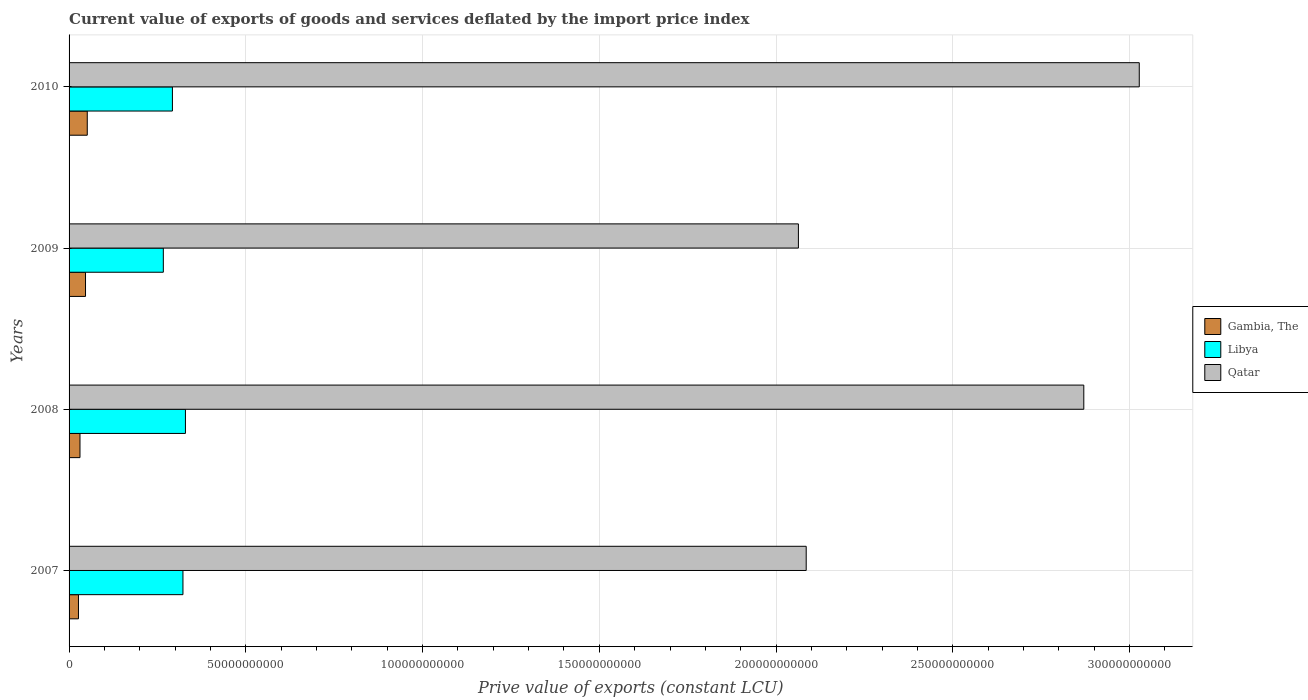How many different coloured bars are there?
Your answer should be compact. 3. How many groups of bars are there?
Make the answer very short. 4. Are the number of bars per tick equal to the number of legend labels?
Provide a short and direct response. Yes. Are the number of bars on each tick of the Y-axis equal?
Make the answer very short. Yes. How many bars are there on the 2nd tick from the bottom?
Provide a succinct answer. 3. What is the label of the 4th group of bars from the top?
Give a very brief answer. 2007. What is the prive value of exports in Qatar in 2007?
Keep it short and to the point. 2.09e+11. Across all years, what is the maximum prive value of exports in Qatar?
Your response must be concise. 3.03e+11. Across all years, what is the minimum prive value of exports in Qatar?
Give a very brief answer. 2.06e+11. In which year was the prive value of exports in Libya maximum?
Offer a very short reply. 2008. In which year was the prive value of exports in Gambia, The minimum?
Ensure brevity in your answer.  2007. What is the total prive value of exports in Gambia, The in the graph?
Your answer should be compact. 1.55e+1. What is the difference between the prive value of exports in Gambia, The in 2007 and that in 2009?
Keep it short and to the point. -1.99e+09. What is the difference between the prive value of exports in Qatar in 2009 and the prive value of exports in Libya in 2008?
Give a very brief answer. 1.73e+11. What is the average prive value of exports in Qatar per year?
Provide a short and direct response. 2.51e+11. In the year 2008, what is the difference between the prive value of exports in Gambia, The and prive value of exports in Qatar?
Offer a very short reply. -2.84e+11. What is the ratio of the prive value of exports in Libya in 2009 to that in 2010?
Offer a terse response. 0.91. Is the prive value of exports in Libya in 2008 less than that in 2010?
Ensure brevity in your answer.  No. What is the difference between the highest and the second highest prive value of exports in Qatar?
Provide a succinct answer. 1.57e+1. What is the difference between the highest and the lowest prive value of exports in Gambia, The?
Make the answer very short. 2.49e+09. In how many years, is the prive value of exports in Gambia, The greater than the average prive value of exports in Gambia, The taken over all years?
Provide a short and direct response. 2. What does the 2nd bar from the top in 2009 represents?
Offer a terse response. Libya. What does the 3rd bar from the bottom in 2007 represents?
Offer a terse response. Qatar. Is it the case that in every year, the sum of the prive value of exports in Qatar and prive value of exports in Libya is greater than the prive value of exports in Gambia, The?
Provide a short and direct response. Yes. Are all the bars in the graph horizontal?
Make the answer very short. Yes. Are the values on the major ticks of X-axis written in scientific E-notation?
Offer a terse response. No. How many legend labels are there?
Provide a short and direct response. 3. What is the title of the graph?
Provide a short and direct response. Current value of exports of goods and services deflated by the import price index. What is the label or title of the X-axis?
Your answer should be compact. Prive value of exports (constant LCU). What is the label or title of the Y-axis?
Make the answer very short. Years. What is the Prive value of exports (constant LCU) in Gambia, The in 2007?
Provide a short and direct response. 2.66e+09. What is the Prive value of exports (constant LCU) in Libya in 2007?
Your answer should be compact. 3.22e+1. What is the Prive value of exports (constant LCU) in Qatar in 2007?
Give a very brief answer. 2.09e+11. What is the Prive value of exports (constant LCU) of Gambia, The in 2008?
Keep it short and to the point. 3.09e+09. What is the Prive value of exports (constant LCU) of Libya in 2008?
Provide a short and direct response. 3.29e+1. What is the Prive value of exports (constant LCU) in Qatar in 2008?
Your answer should be very brief. 2.87e+11. What is the Prive value of exports (constant LCU) in Gambia, The in 2009?
Your response must be concise. 4.65e+09. What is the Prive value of exports (constant LCU) in Libya in 2009?
Keep it short and to the point. 2.67e+1. What is the Prive value of exports (constant LCU) in Qatar in 2009?
Your response must be concise. 2.06e+11. What is the Prive value of exports (constant LCU) of Gambia, The in 2010?
Ensure brevity in your answer.  5.15e+09. What is the Prive value of exports (constant LCU) in Libya in 2010?
Your answer should be very brief. 2.92e+1. What is the Prive value of exports (constant LCU) in Qatar in 2010?
Give a very brief answer. 3.03e+11. Across all years, what is the maximum Prive value of exports (constant LCU) of Gambia, The?
Give a very brief answer. 5.15e+09. Across all years, what is the maximum Prive value of exports (constant LCU) in Libya?
Your answer should be compact. 3.29e+1. Across all years, what is the maximum Prive value of exports (constant LCU) in Qatar?
Make the answer very short. 3.03e+11. Across all years, what is the minimum Prive value of exports (constant LCU) in Gambia, The?
Your answer should be very brief. 2.66e+09. Across all years, what is the minimum Prive value of exports (constant LCU) of Libya?
Provide a succinct answer. 2.67e+1. Across all years, what is the minimum Prive value of exports (constant LCU) of Qatar?
Provide a succinct answer. 2.06e+11. What is the total Prive value of exports (constant LCU) in Gambia, The in the graph?
Give a very brief answer. 1.55e+1. What is the total Prive value of exports (constant LCU) of Libya in the graph?
Your answer should be compact. 1.21e+11. What is the total Prive value of exports (constant LCU) of Qatar in the graph?
Ensure brevity in your answer.  1.00e+12. What is the difference between the Prive value of exports (constant LCU) of Gambia, The in 2007 and that in 2008?
Provide a short and direct response. -4.27e+08. What is the difference between the Prive value of exports (constant LCU) in Libya in 2007 and that in 2008?
Offer a terse response. -7.04e+08. What is the difference between the Prive value of exports (constant LCU) in Qatar in 2007 and that in 2008?
Your response must be concise. -7.85e+1. What is the difference between the Prive value of exports (constant LCU) in Gambia, The in 2007 and that in 2009?
Give a very brief answer. -1.99e+09. What is the difference between the Prive value of exports (constant LCU) of Libya in 2007 and that in 2009?
Make the answer very short. 5.55e+09. What is the difference between the Prive value of exports (constant LCU) in Qatar in 2007 and that in 2009?
Your answer should be compact. 2.21e+09. What is the difference between the Prive value of exports (constant LCU) in Gambia, The in 2007 and that in 2010?
Provide a short and direct response. -2.49e+09. What is the difference between the Prive value of exports (constant LCU) in Libya in 2007 and that in 2010?
Keep it short and to the point. 2.98e+09. What is the difference between the Prive value of exports (constant LCU) in Qatar in 2007 and that in 2010?
Provide a short and direct response. -9.42e+1. What is the difference between the Prive value of exports (constant LCU) of Gambia, The in 2008 and that in 2009?
Offer a very short reply. -1.57e+09. What is the difference between the Prive value of exports (constant LCU) of Libya in 2008 and that in 2009?
Give a very brief answer. 6.26e+09. What is the difference between the Prive value of exports (constant LCU) in Qatar in 2008 and that in 2009?
Provide a short and direct response. 8.07e+1. What is the difference between the Prive value of exports (constant LCU) in Gambia, The in 2008 and that in 2010?
Give a very brief answer. -2.06e+09. What is the difference between the Prive value of exports (constant LCU) in Libya in 2008 and that in 2010?
Give a very brief answer. 3.68e+09. What is the difference between the Prive value of exports (constant LCU) in Qatar in 2008 and that in 2010?
Ensure brevity in your answer.  -1.57e+1. What is the difference between the Prive value of exports (constant LCU) of Gambia, The in 2009 and that in 2010?
Offer a very short reply. -4.93e+08. What is the difference between the Prive value of exports (constant LCU) in Libya in 2009 and that in 2010?
Give a very brief answer. -2.57e+09. What is the difference between the Prive value of exports (constant LCU) of Qatar in 2009 and that in 2010?
Give a very brief answer. -9.64e+1. What is the difference between the Prive value of exports (constant LCU) in Gambia, The in 2007 and the Prive value of exports (constant LCU) in Libya in 2008?
Give a very brief answer. -3.03e+1. What is the difference between the Prive value of exports (constant LCU) of Gambia, The in 2007 and the Prive value of exports (constant LCU) of Qatar in 2008?
Your answer should be compact. -2.84e+11. What is the difference between the Prive value of exports (constant LCU) in Libya in 2007 and the Prive value of exports (constant LCU) in Qatar in 2008?
Offer a terse response. -2.55e+11. What is the difference between the Prive value of exports (constant LCU) in Gambia, The in 2007 and the Prive value of exports (constant LCU) in Libya in 2009?
Keep it short and to the point. -2.40e+1. What is the difference between the Prive value of exports (constant LCU) of Gambia, The in 2007 and the Prive value of exports (constant LCU) of Qatar in 2009?
Give a very brief answer. -2.04e+11. What is the difference between the Prive value of exports (constant LCU) of Libya in 2007 and the Prive value of exports (constant LCU) of Qatar in 2009?
Offer a very short reply. -1.74e+11. What is the difference between the Prive value of exports (constant LCU) in Gambia, The in 2007 and the Prive value of exports (constant LCU) in Libya in 2010?
Provide a short and direct response. -2.66e+1. What is the difference between the Prive value of exports (constant LCU) of Gambia, The in 2007 and the Prive value of exports (constant LCU) of Qatar in 2010?
Provide a succinct answer. -3.00e+11. What is the difference between the Prive value of exports (constant LCU) of Libya in 2007 and the Prive value of exports (constant LCU) of Qatar in 2010?
Offer a terse response. -2.71e+11. What is the difference between the Prive value of exports (constant LCU) of Gambia, The in 2008 and the Prive value of exports (constant LCU) of Libya in 2009?
Offer a very short reply. -2.36e+1. What is the difference between the Prive value of exports (constant LCU) in Gambia, The in 2008 and the Prive value of exports (constant LCU) in Qatar in 2009?
Make the answer very short. -2.03e+11. What is the difference between the Prive value of exports (constant LCU) of Libya in 2008 and the Prive value of exports (constant LCU) of Qatar in 2009?
Provide a succinct answer. -1.73e+11. What is the difference between the Prive value of exports (constant LCU) of Gambia, The in 2008 and the Prive value of exports (constant LCU) of Libya in 2010?
Your response must be concise. -2.61e+1. What is the difference between the Prive value of exports (constant LCU) of Gambia, The in 2008 and the Prive value of exports (constant LCU) of Qatar in 2010?
Your response must be concise. -3.00e+11. What is the difference between the Prive value of exports (constant LCU) of Libya in 2008 and the Prive value of exports (constant LCU) of Qatar in 2010?
Make the answer very short. -2.70e+11. What is the difference between the Prive value of exports (constant LCU) of Gambia, The in 2009 and the Prive value of exports (constant LCU) of Libya in 2010?
Keep it short and to the point. -2.46e+1. What is the difference between the Prive value of exports (constant LCU) of Gambia, The in 2009 and the Prive value of exports (constant LCU) of Qatar in 2010?
Provide a short and direct response. -2.98e+11. What is the difference between the Prive value of exports (constant LCU) of Libya in 2009 and the Prive value of exports (constant LCU) of Qatar in 2010?
Your response must be concise. -2.76e+11. What is the average Prive value of exports (constant LCU) in Gambia, The per year?
Your answer should be very brief. 3.89e+09. What is the average Prive value of exports (constant LCU) of Libya per year?
Your answer should be compact. 3.03e+1. What is the average Prive value of exports (constant LCU) in Qatar per year?
Provide a short and direct response. 2.51e+11. In the year 2007, what is the difference between the Prive value of exports (constant LCU) of Gambia, The and Prive value of exports (constant LCU) of Libya?
Your answer should be compact. -2.96e+1. In the year 2007, what is the difference between the Prive value of exports (constant LCU) of Gambia, The and Prive value of exports (constant LCU) of Qatar?
Ensure brevity in your answer.  -2.06e+11. In the year 2007, what is the difference between the Prive value of exports (constant LCU) in Libya and Prive value of exports (constant LCU) in Qatar?
Your response must be concise. -1.76e+11. In the year 2008, what is the difference between the Prive value of exports (constant LCU) in Gambia, The and Prive value of exports (constant LCU) in Libya?
Ensure brevity in your answer.  -2.98e+1. In the year 2008, what is the difference between the Prive value of exports (constant LCU) of Gambia, The and Prive value of exports (constant LCU) of Qatar?
Your response must be concise. -2.84e+11. In the year 2008, what is the difference between the Prive value of exports (constant LCU) in Libya and Prive value of exports (constant LCU) in Qatar?
Offer a very short reply. -2.54e+11. In the year 2009, what is the difference between the Prive value of exports (constant LCU) of Gambia, The and Prive value of exports (constant LCU) of Libya?
Ensure brevity in your answer.  -2.20e+1. In the year 2009, what is the difference between the Prive value of exports (constant LCU) in Gambia, The and Prive value of exports (constant LCU) in Qatar?
Offer a very short reply. -2.02e+11. In the year 2009, what is the difference between the Prive value of exports (constant LCU) in Libya and Prive value of exports (constant LCU) in Qatar?
Your response must be concise. -1.80e+11. In the year 2010, what is the difference between the Prive value of exports (constant LCU) in Gambia, The and Prive value of exports (constant LCU) in Libya?
Keep it short and to the point. -2.41e+1. In the year 2010, what is the difference between the Prive value of exports (constant LCU) of Gambia, The and Prive value of exports (constant LCU) of Qatar?
Provide a succinct answer. -2.98e+11. In the year 2010, what is the difference between the Prive value of exports (constant LCU) in Libya and Prive value of exports (constant LCU) in Qatar?
Ensure brevity in your answer.  -2.73e+11. What is the ratio of the Prive value of exports (constant LCU) in Gambia, The in 2007 to that in 2008?
Your response must be concise. 0.86. What is the ratio of the Prive value of exports (constant LCU) of Libya in 2007 to that in 2008?
Give a very brief answer. 0.98. What is the ratio of the Prive value of exports (constant LCU) of Qatar in 2007 to that in 2008?
Your response must be concise. 0.73. What is the ratio of the Prive value of exports (constant LCU) in Gambia, The in 2007 to that in 2009?
Your answer should be compact. 0.57. What is the ratio of the Prive value of exports (constant LCU) in Libya in 2007 to that in 2009?
Your answer should be compact. 1.21. What is the ratio of the Prive value of exports (constant LCU) in Qatar in 2007 to that in 2009?
Your response must be concise. 1.01. What is the ratio of the Prive value of exports (constant LCU) in Gambia, The in 2007 to that in 2010?
Your response must be concise. 0.52. What is the ratio of the Prive value of exports (constant LCU) in Libya in 2007 to that in 2010?
Keep it short and to the point. 1.1. What is the ratio of the Prive value of exports (constant LCU) in Qatar in 2007 to that in 2010?
Your answer should be very brief. 0.69. What is the ratio of the Prive value of exports (constant LCU) of Gambia, The in 2008 to that in 2009?
Offer a very short reply. 0.66. What is the ratio of the Prive value of exports (constant LCU) of Libya in 2008 to that in 2009?
Provide a succinct answer. 1.23. What is the ratio of the Prive value of exports (constant LCU) of Qatar in 2008 to that in 2009?
Give a very brief answer. 1.39. What is the ratio of the Prive value of exports (constant LCU) in Gambia, The in 2008 to that in 2010?
Your answer should be very brief. 0.6. What is the ratio of the Prive value of exports (constant LCU) of Libya in 2008 to that in 2010?
Your answer should be very brief. 1.13. What is the ratio of the Prive value of exports (constant LCU) of Qatar in 2008 to that in 2010?
Your answer should be compact. 0.95. What is the ratio of the Prive value of exports (constant LCU) in Gambia, The in 2009 to that in 2010?
Provide a short and direct response. 0.9. What is the ratio of the Prive value of exports (constant LCU) in Libya in 2009 to that in 2010?
Give a very brief answer. 0.91. What is the ratio of the Prive value of exports (constant LCU) of Qatar in 2009 to that in 2010?
Offer a very short reply. 0.68. What is the difference between the highest and the second highest Prive value of exports (constant LCU) of Gambia, The?
Your answer should be very brief. 4.93e+08. What is the difference between the highest and the second highest Prive value of exports (constant LCU) in Libya?
Your answer should be compact. 7.04e+08. What is the difference between the highest and the second highest Prive value of exports (constant LCU) in Qatar?
Your answer should be very brief. 1.57e+1. What is the difference between the highest and the lowest Prive value of exports (constant LCU) in Gambia, The?
Offer a terse response. 2.49e+09. What is the difference between the highest and the lowest Prive value of exports (constant LCU) in Libya?
Your response must be concise. 6.26e+09. What is the difference between the highest and the lowest Prive value of exports (constant LCU) of Qatar?
Offer a terse response. 9.64e+1. 